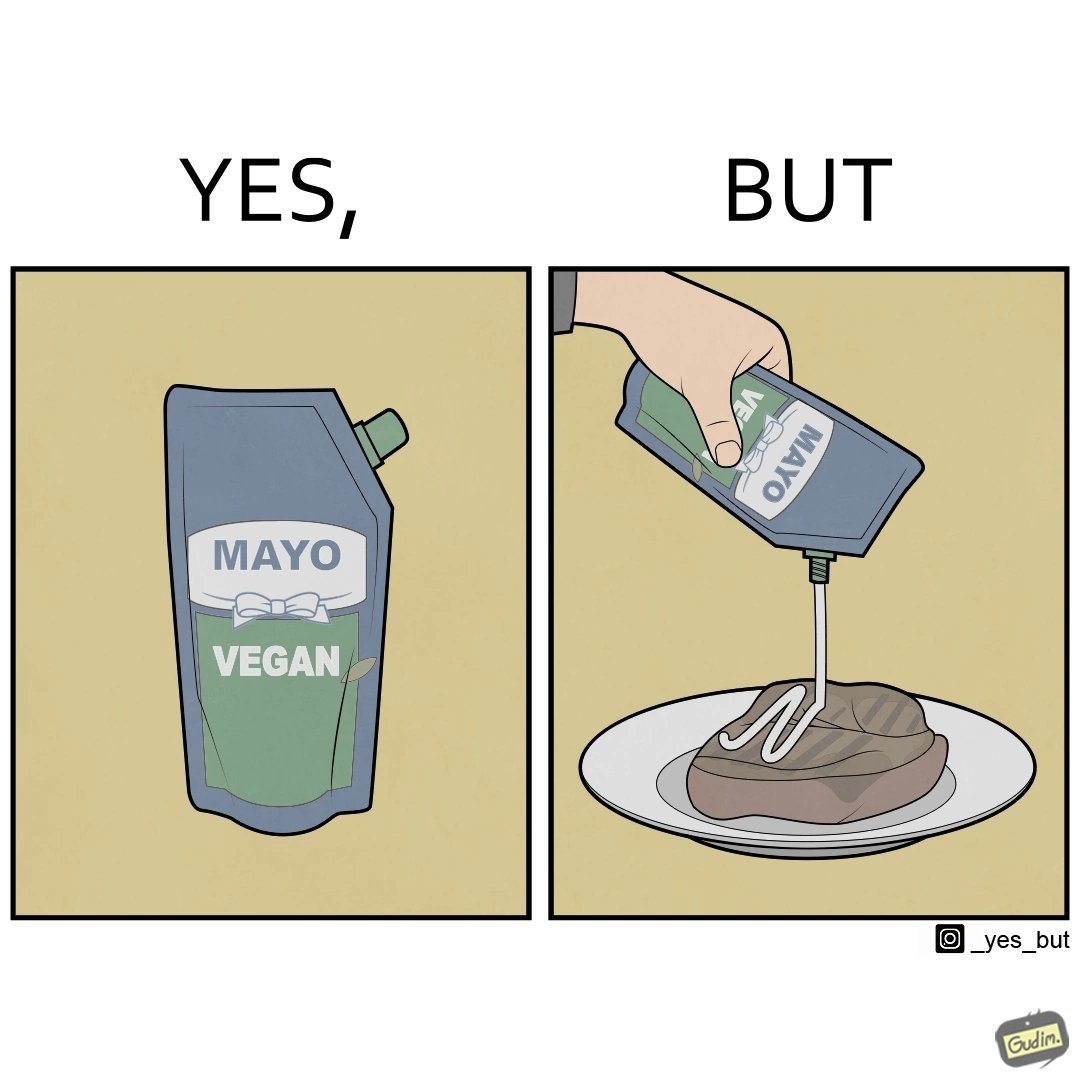Provide a description of this image. The image is ironical, as vegan mayo sauce is being poured on rib steak, which is non-vegetarian. The person might as well just use normal mayo sauce instead. 